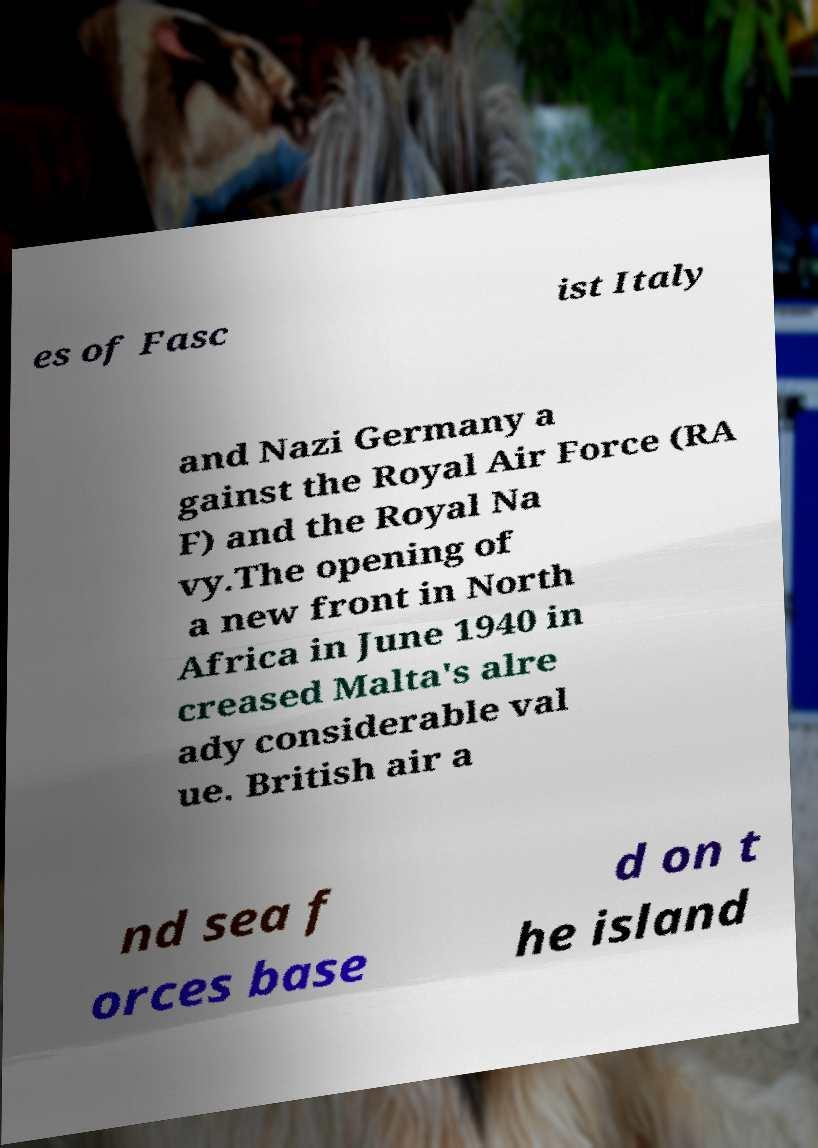I need the written content from this picture converted into text. Can you do that? es of Fasc ist Italy and Nazi Germany a gainst the Royal Air Force (RA F) and the Royal Na vy.The opening of a new front in North Africa in June 1940 in creased Malta's alre ady considerable val ue. British air a nd sea f orces base d on t he island 